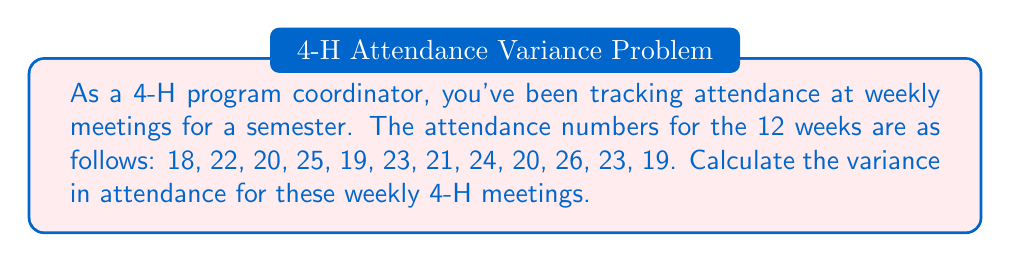Help me with this question. To calculate the variance, we'll follow these steps:

1. Calculate the mean attendance:
   $\bar{x} = \frac{\sum_{i=1}^{n} x_i}{n} = \frac{18 + 22 + 20 + 25 + 19 + 23 + 21 + 24 + 20 + 26 + 23 + 19}{12} = \frac{260}{12} = 21.67$

2. Calculate the squared differences from the mean:
   $(18 - 21.67)^2 = 13.44$
   $(22 - 21.67)^2 = 0.11$
   $(20 - 21.67)^2 = 2.78$
   $(25 - 21.67)^2 = 11.11$
   $(19 - 21.67)^2 = 7.11$
   $(23 - 21.67)^2 = 1.78$
   $(21 - 21.67)^2 = 0.44$
   $(24 - 21.67)^2 = 5.44$
   $(20 - 21.67)^2 = 2.78$
   $(26 - 21.67)^2 = 18.78$
   $(23 - 21.67)^2 = 1.78$
   $(19 - 21.67)^2 = 7.11$

3. Sum the squared differences:
   $\sum_{i=1}^{n} (x_i - \bar{x})^2 = 72.66$

4. Calculate the variance using the formula:
   $$\text{Variance} = \frac{\sum_{i=1}^{n} (x_i - \bar{x})^2}{n - 1} = \frac{72.66}{11} = 6.61$$

The variance in attendance for the weekly 4-H meetings over the semester is approximately 6.61.
Answer: $6.61$ 